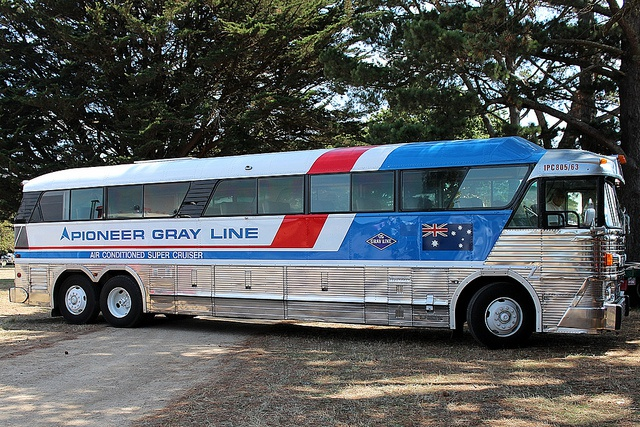Describe the objects in this image and their specific colors. I can see bus in black, gray, lightgray, and darkgray tones and people in black, gray, and teal tones in this image. 